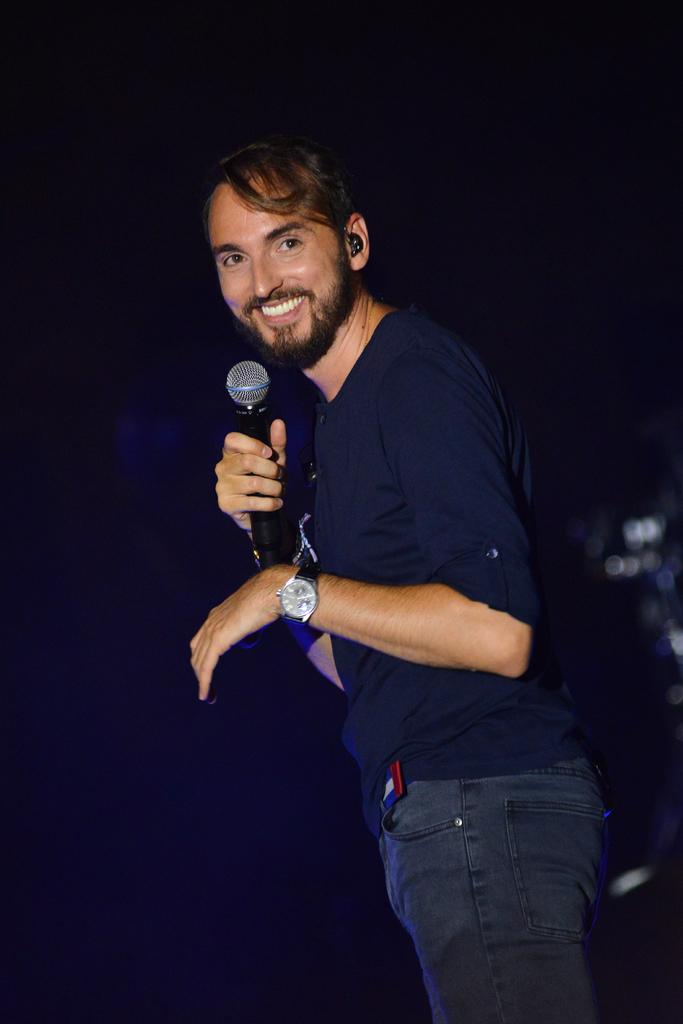What is the person in the image doing? The person is standing in the image. What color is the shirt the person is wearing? The person is wearing a blue shirt. What color are the pants the person is wearing? The person is wearing gray pants. What object is the person holding in the image? The person is holding a microphone. What can be observed about the background of the image? The background of the image is dark. What type of jelly is being used as a prop in the image? There is no jelly present in the image. How does the tramp interact with the person in the image? There is no tramp present in the image. 